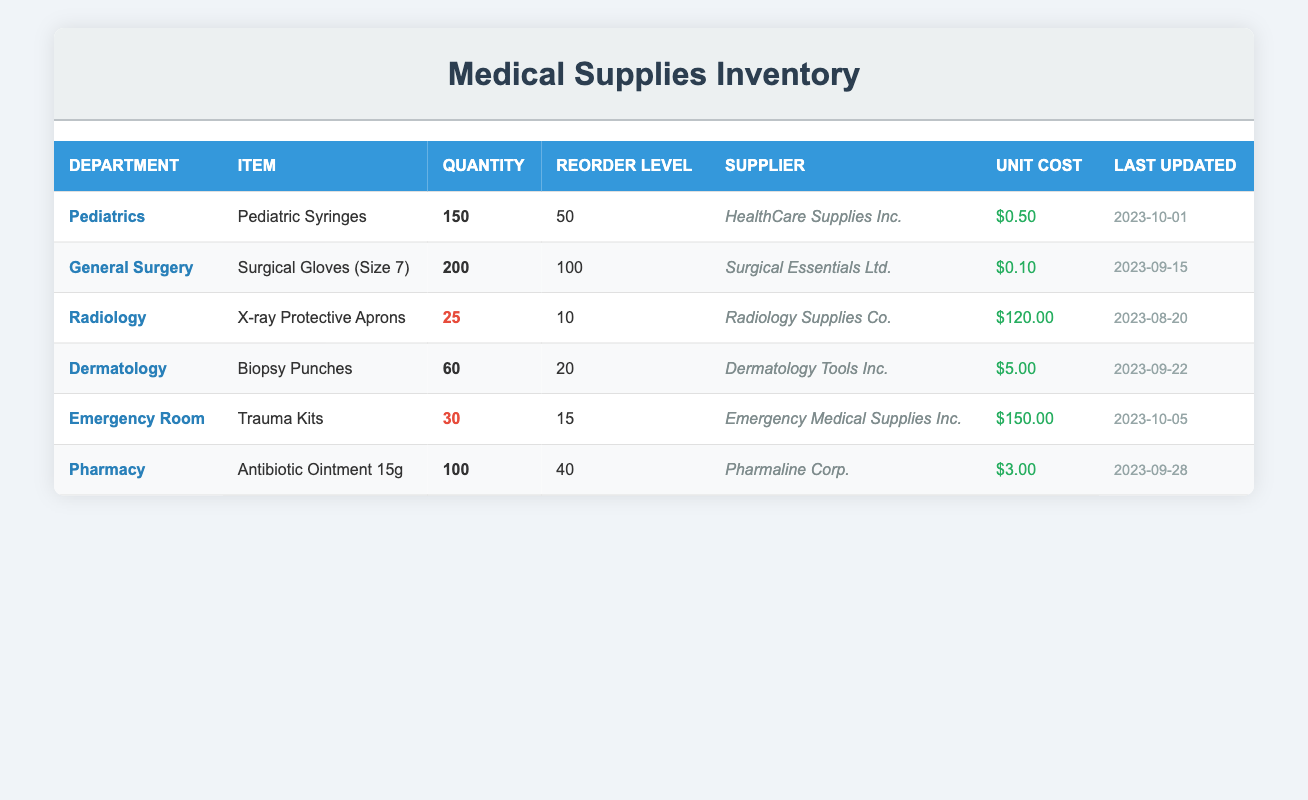What is the quantity on hand for Pediatric Syringes? The table lists the item "Pediatric Syringes" under the "Pediatrics" department, with a corresponding quantity of 150.
Answer: 150 How many Surgical Gloves (Size 7) are available? The entry for "Surgical Gloves (Size 7)" under the "General Surgery" department shows a quantity of 200 on hand.
Answer: 200 What is the reorder level for X-ray Protective Aprons? The reorder level for the item "X-ray Protective Aprons" in the "Radiology" department is indicated as 10 in the table.
Answer: 10 Are there more than 100 quantities of Antibiotic Ointment 15g in stock? The table states that there are 100 units of "Antibiotic Ointment 15g" in the "Pharmacy" department, which is not greater than 100.
Answer: No How many items are below their reorder levels? The items with quantities below reorder levels in the table are "X-ray Protective Aprons" (25), and "Trauma Kits" (30), which totals 2 items.
Answer: 2 What is the total quantity of all medical supplies on hand? The quantities to sum are: 150 (Pediatrics) + 200 (General Surgery) + 25 (Radiology) + 60 (Dermatology) + 30 (Emergency Room) + 100 (Pharmacy) = 565.
Answer: 565 Which department has the highest unit cost for supplies, and what is the cost? The "Emergency Room" has the highest unit cost for "Trauma Kits" at $150.00 as shown in the table.
Answer: Emergency Room, $150.00 True or False: Dermatology has more items than Pediatrics. The table shows 1 item listed for "Dermatology" and 1 item for "Pediatrics", indicating they have the same number of items.
Answer: False What is the last updated date for the supplies in the Pharmacy department? The entry for the "Pharmacy" indicates that the last updated date for "Antibiotic Ointment 15g" is 2023-09-28.
Answer: 2023-09-28 